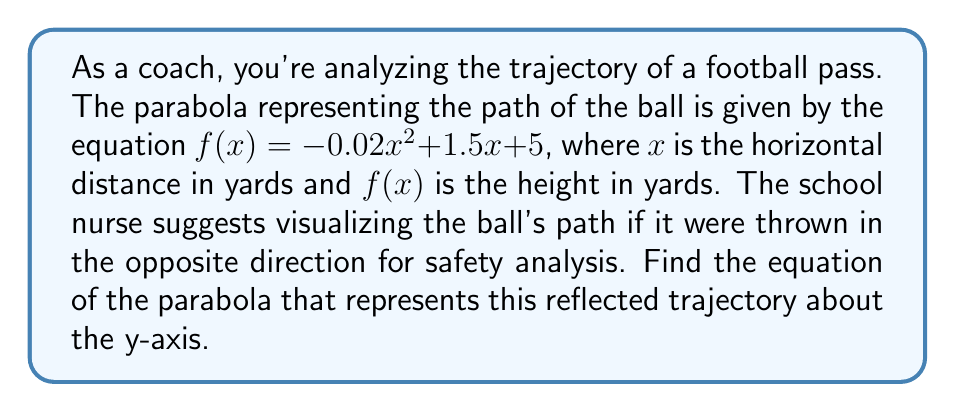Solve this math problem. To find the reflection of the parabola about the y-axis, we need to follow these steps:

1) The general form of a quadratic function is $f(x) = ax^2 + bx + c$.
   In this case, $a = -0.02$, $b = 1.5$, and $c = 5$.

2) To reflect a function about the y-axis, we replace every $x$ with $-x$.
   This gives us: $f(-x) = -0.02(-x)^2 + 1.5(-x) + 5$

3) Simplify:
   $f(-x) = -0.02x^2 - 1.5x + 5$

4) The negative sign in front of the $x$ term changes to positive:
   $f(-x) = -0.02x^2 - 1.5x + 5$

5) Therefore, the reflected parabola has the equation:
   $g(x) = -0.02x^2 - 1.5x + 5$

This new equation represents the trajectory of the ball as if it were thrown in the opposite direction, maintaining the same shape but mirrored across the y-axis.
Answer: $g(x) = -0.02x^2 - 1.5x + 5$ 